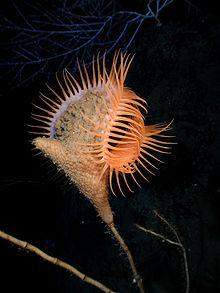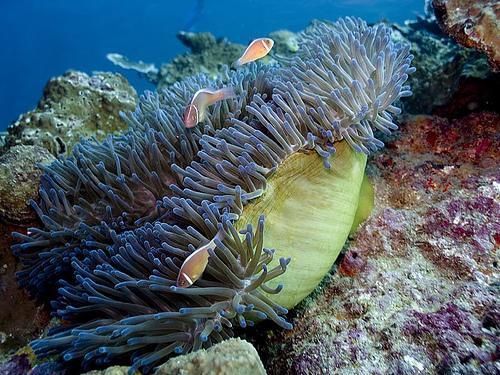The first image is the image on the left, the second image is the image on the right. Evaluate the accuracy of this statement regarding the images: "fish are swimming near anemones". Is it true? Answer yes or no. Yes. 